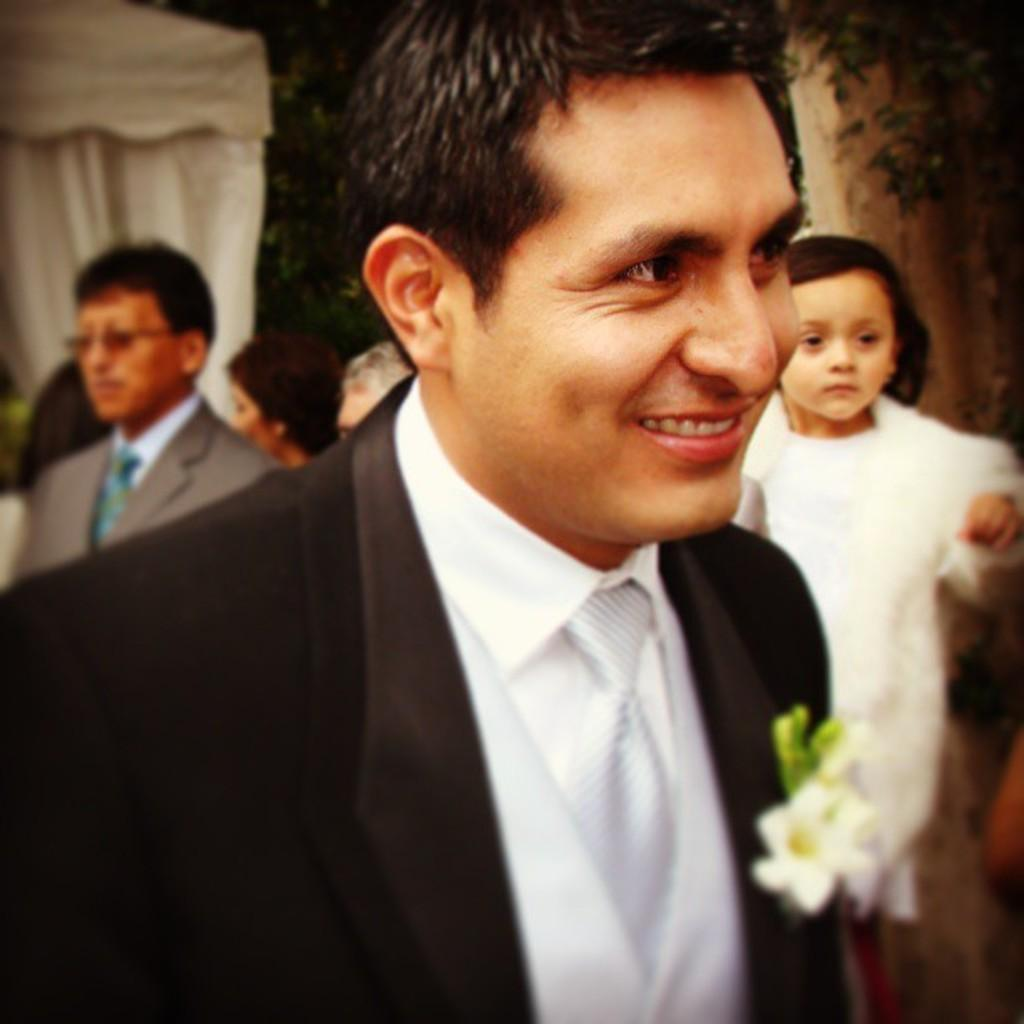What is the person in the image wearing? The person is wearing a tie and a black coat in the image. What is the facial expression of the person in the image? The person is smiling in the image. What can be seen on the coast in the image? There is a flower on the coast in the image. What is visible in the background of the image? There is a girl and other people in the background of the image. What type of pan is the person using to cook in the image? There is no pan or cooking activity present in the image. Can you tell me how many airplanes are flying in the background of the image? There are no airplanes visible in the image; it only shows a person, a flower on the coast, and people in the background. 